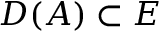Convert formula to latex. <formula><loc_0><loc_0><loc_500><loc_500>D ( A ) \subset E</formula> 